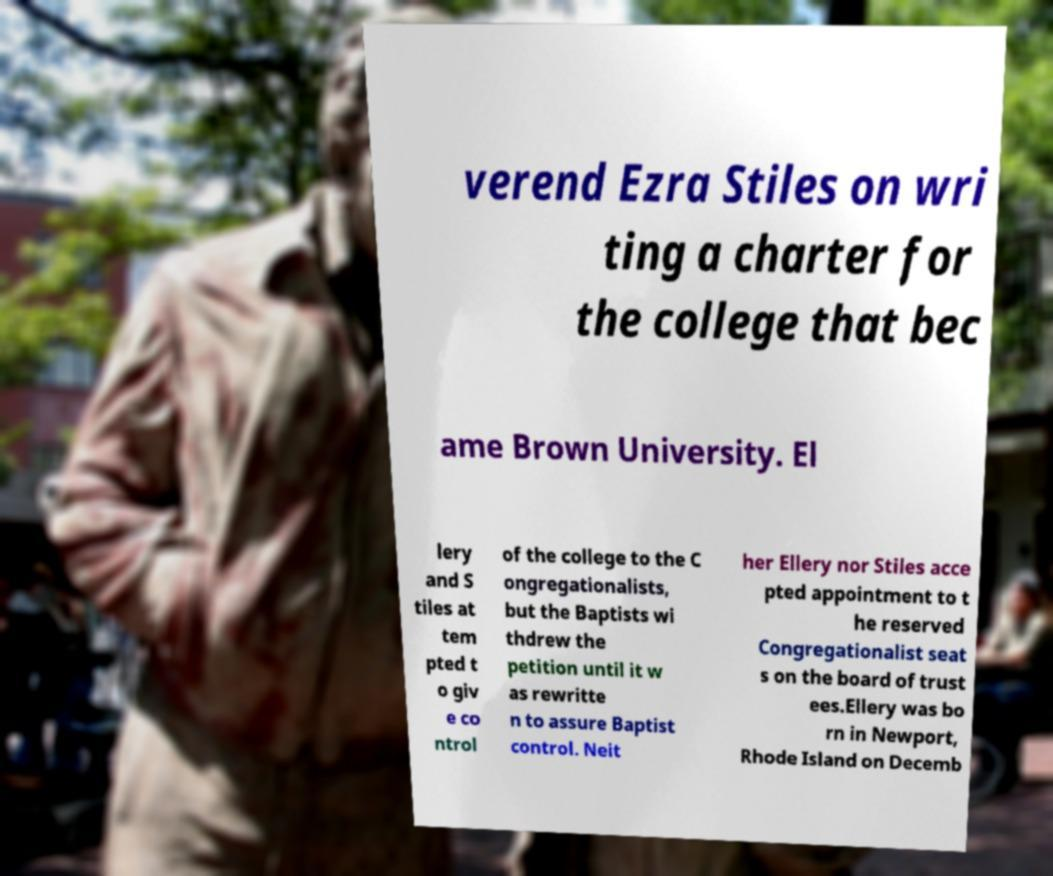I need the written content from this picture converted into text. Can you do that? verend Ezra Stiles on wri ting a charter for the college that bec ame Brown University. El lery and S tiles at tem pted t o giv e co ntrol of the college to the C ongregationalists, but the Baptists wi thdrew the petition until it w as rewritte n to assure Baptist control. Neit her Ellery nor Stiles acce pted appointment to t he reserved Congregationalist seat s on the board of trust ees.Ellery was bo rn in Newport, Rhode Island on Decemb 